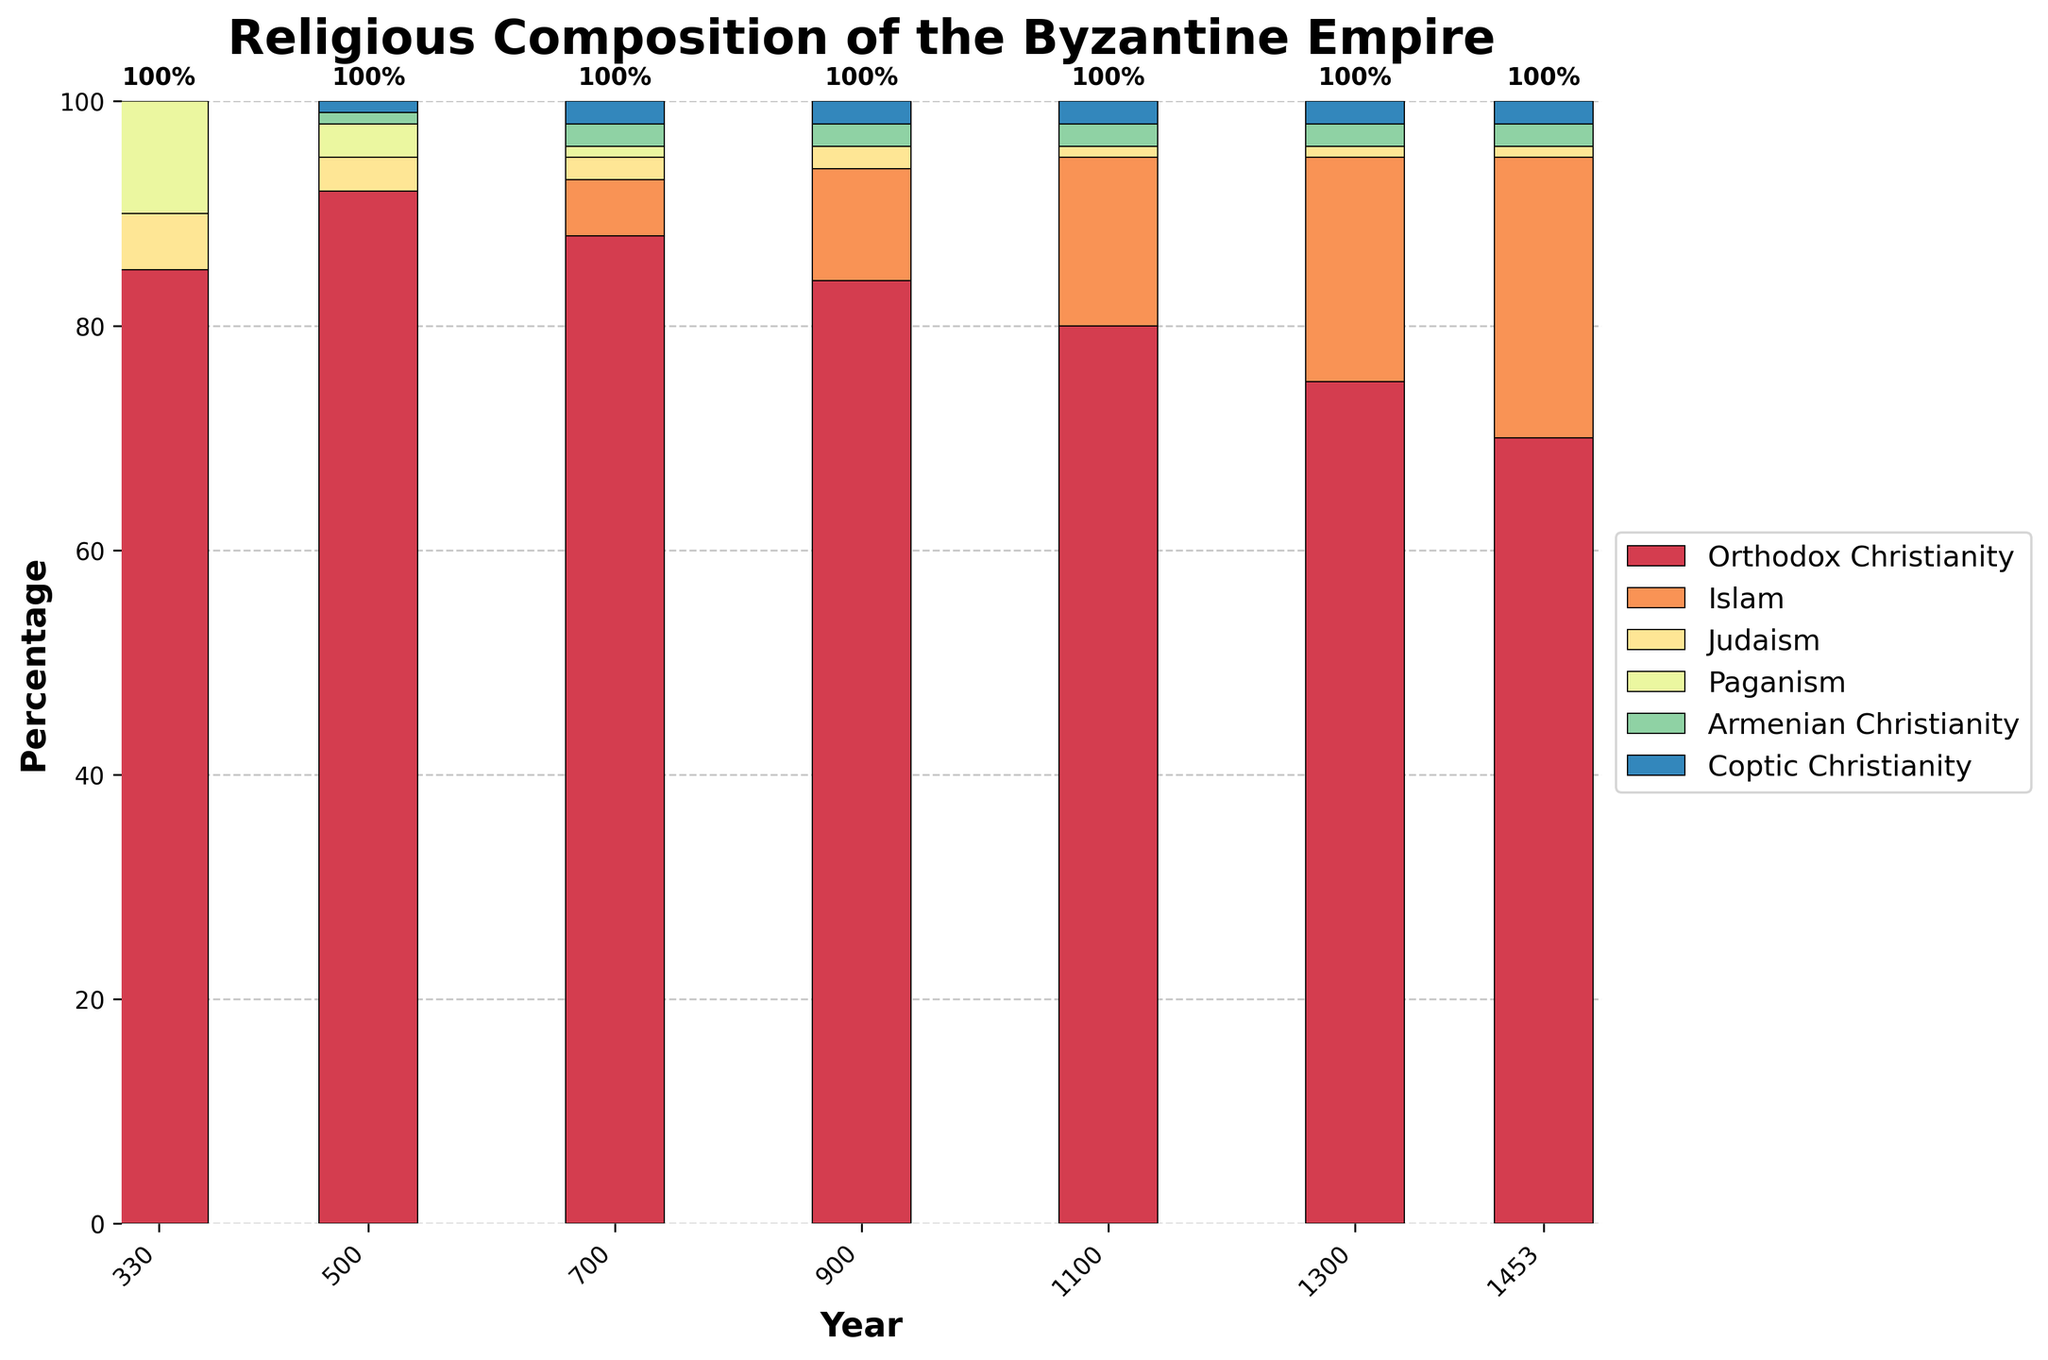What is the percentage of Orthodox Christianity in the year 1100? To find the percentage of Orthodox Christianity in 1100, locate the bar for the year 1100 and observe the height corresponding to Orthodox Christianity.
Answer: 80% How did the percentage of Islam change from 700 to 900? Compare the height of the bar segment representing Islam in the years 700 and 900. Islam increased from 5% in 700 to 10% in 900. The change is 10% - 5% = 5%.
Answer: Increased by 5% Which religion had a constant percentage from 1100 to 1453? Observe the bars for years 1100, 1300, and 1453 and identify any religion whose bar segment height remains the same across these years. The percentages of Armenian Christianity (2%) and Coptic Christianity (2%) remained constant.
Answer: Armenian and Coptic Christianity What is the combined percentage of Paganism and Judaism in the year 500? Locate the bar for 500 and sum the heights of the segments representing Paganism (3%) and Judaism (3%). The combined percentage is 3% + 3% = 6%.
Answer: 6% By how much did the percentage of Orthodox Christianity decrease from 1100 to 1453? Compare the height of the bar segment for Orthodox Christianity in the years 1100 and 1453. Orthodox Christianity decreased from 80% in 1100 to 70% in 1453. The decrease is 80% - 70% = 10%.
Answer: Decreased by 10% Which year saw the highest percentage of Orthodox Christianity? Compare the heights of the bar segments representing Orthodox Christianity across all the years. The year with the highest percentage (92%) is 500.
Answer: 500 In which year did Islam first appear in the religious composition of the Byzantine Empire? Identify the earliest year in which a bar segment for Islam is visible. The first appearance of Islam occurred in the year 700.
Answer: 700 What was the overall trend of Paganism from 330 to 1100? Examine the heights of the bar segments for Paganism over the years from 330 to 1100. Paganism decreased steadily from 10% in 330 to 0% in 900 and beyond.
Answer: Decreasing trend 